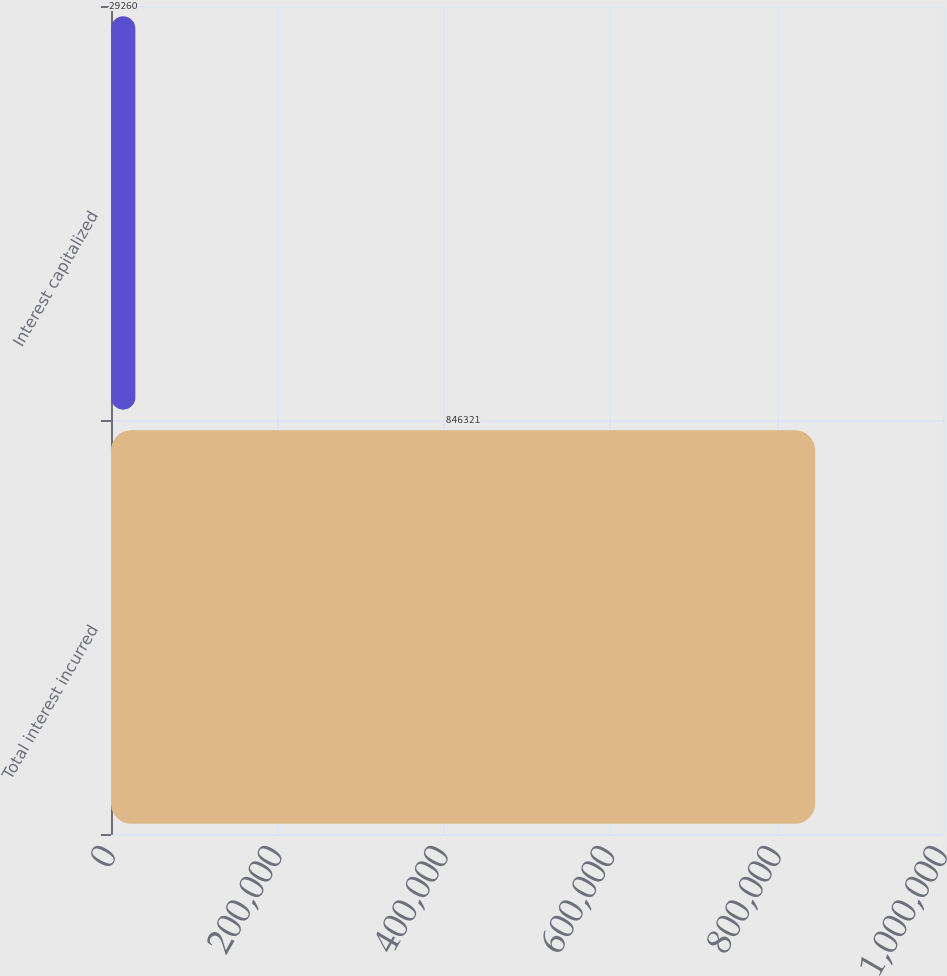Convert chart to OTSL. <chart><loc_0><loc_0><loc_500><loc_500><bar_chart><fcel>Total interest incurred<fcel>Interest capitalized<nl><fcel>846321<fcel>29260<nl></chart> 